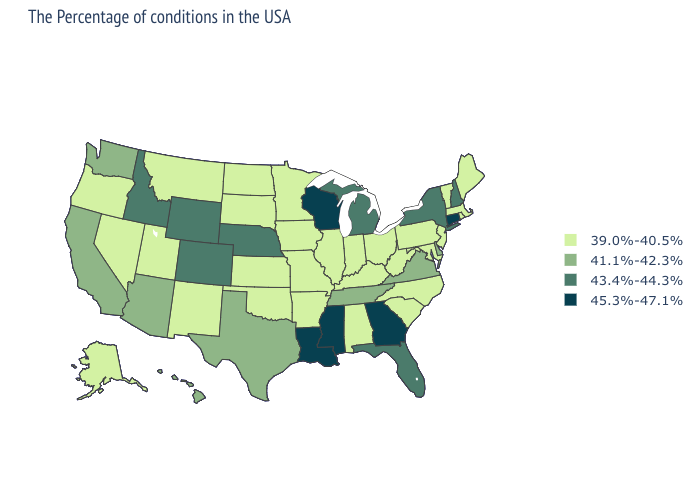Name the states that have a value in the range 41.1%-42.3%?
Keep it brief. Delaware, Virginia, Tennessee, Texas, Arizona, California, Washington, Hawaii. What is the highest value in the USA?
Write a very short answer. 45.3%-47.1%. Does Connecticut have the highest value in the USA?
Short answer required. Yes. Name the states that have a value in the range 39.0%-40.5%?
Concise answer only. Maine, Massachusetts, Rhode Island, Vermont, New Jersey, Maryland, Pennsylvania, North Carolina, South Carolina, West Virginia, Ohio, Kentucky, Indiana, Alabama, Illinois, Missouri, Arkansas, Minnesota, Iowa, Kansas, Oklahoma, South Dakota, North Dakota, New Mexico, Utah, Montana, Nevada, Oregon, Alaska. Which states hav the highest value in the West?
Concise answer only. Wyoming, Colorado, Idaho. Which states have the lowest value in the MidWest?
Answer briefly. Ohio, Indiana, Illinois, Missouri, Minnesota, Iowa, Kansas, South Dakota, North Dakota. What is the value of New Mexico?
Give a very brief answer. 39.0%-40.5%. Name the states that have a value in the range 39.0%-40.5%?
Keep it brief. Maine, Massachusetts, Rhode Island, Vermont, New Jersey, Maryland, Pennsylvania, North Carolina, South Carolina, West Virginia, Ohio, Kentucky, Indiana, Alabama, Illinois, Missouri, Arkansas, Minnesota, Iowa, Kansas, Oklahoma, South Dakota, North Dakota, New Mexico, Utah, Montana, Nevada, Oregon, Alaska. What is the lowest value in the USA?
Concise answer only. 39.0%-40.5%. Among the states that border Indiana , does Michigan have the highest value?
Short answer required. Yes. Which states have the lowest value in the USA?
Answer briefly. Maine, Massachusetts, Rhode Island, Vermont, New Jersey, Maryland, Pennsylvania, North Carolina, South Carolina, West Virginia, Ohio, Kentucky, Indiana, Alabama, Illinois, Missouri, Arkansas, Minnesota, Iowa, Kansas, Oklahoma, South Dakota, North Dakota, New Mexico, Utah, Montana, Nevada, Oregon, Alaska. Among the states that border Ohio , which have the highest value?
Keep it brief. Michigan. Among the states that border Indiana , does Kentucky have the highest value?
Write a very short answer. No. Does the first symbol in the legend represent the smallest category?
Answer briefly. Yes. Among the states that border Maine , which have the highest value?
Write a very short answer. New Hampshire. 